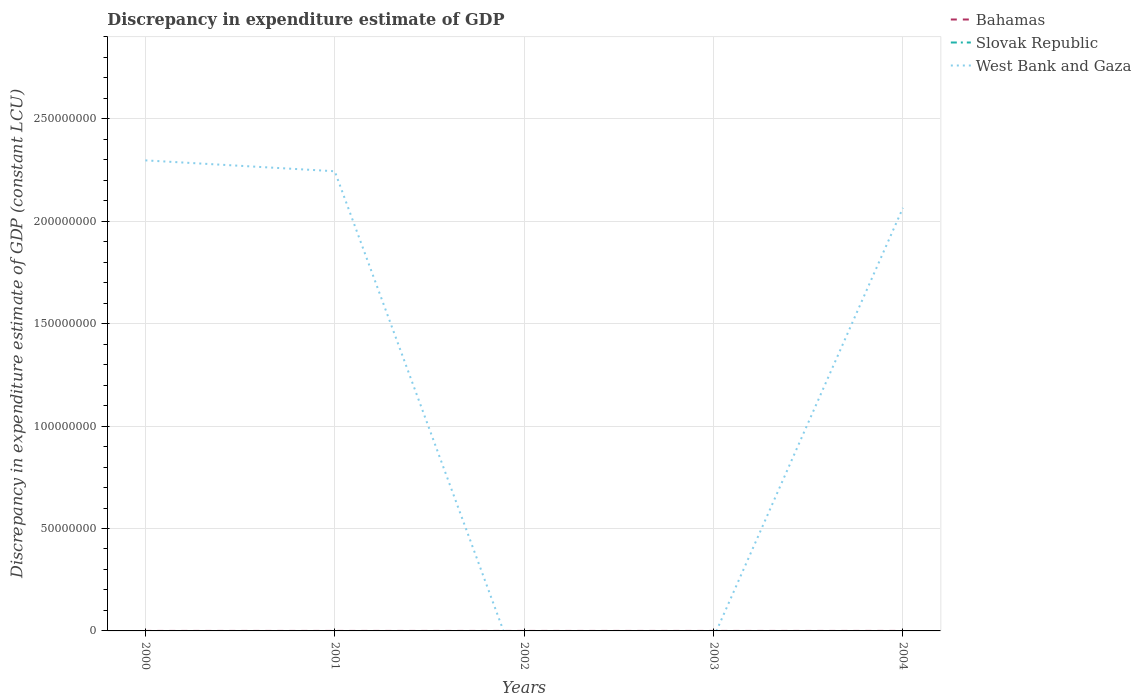How many different coloured lines are there?
Keep it short and to the point. 2. Is the number of lines equal to the number of legend labels?
Offer a very short reply. No. What is the total discrepancy in expenditure estimate of GDP in West Bank and Gaza in the graph?
Provide a succinct answer. 1.79e+07. What is the difference between the highest and the second highest discrepancy in expenditure estimate of GDP in West Bank and Gaza?
Provide a succinct answer. 2.30e+08. Is the discrepancy in expenditure estimate of GDP in Slovak Republic strictly greater than the discrepancy in expenditure estimate of GDP in Bahamas over the years?
Offer a terse response. Yes. How many lines are there?
Make the answer very short. 2. Are the values on the major ticks of Y-axis written in scientific E-notation?
Keep it short and to the point. No. Does the graph contain any zero values?
Your response must be concise. Yes. Does the graph contain grids?
Offer a very short reply. Yes. How many legend labels are there?
Offer a very short reply. 3. How are the legend labels stacked?
Give a very brief answer. Vertical. What is the title of the graph?
Your answer should be compact. Discrepancy in expenditure estimate of GDP. What is the label or title of the Y-axis?
Make the answer very short. Discrepancy in expenditure estimate of GDP (constant LCU). What is the Discrepancy in expenditure estimate of GDP (constant LCU) of Bahamas in 2000?
Provide a succinct answer. 0. What is the Discrepancy in expenditure estimate of GDP (constant LCU) in Slovak Republic in 2000?
Offer a very short reply. 0. What is the Discrepancy in expenditure estimate of GDP (constant LCU) of West Bank and Gaza in 2000?
Give a very brief answer. 2.30e+08. What is the Discrepancy in expenditure estimate of GDP (constant LCU) of West Bank and Gaza in 2001?
Make the answer very short. 2.24e+08. What is the Discrepancy in expenditure estimate of GDP (constant LCU) in Slovak Republic in 2002?
Keep it short and to the point. 0. What is the Discrepancy in expenditure estimate of GDP (constant LCU) of Slovak Republic in 2003?
Offer a terse response. 0. What is the Discrepancy in expenditure estimate of GDP (constant LCU) of Bahamas in 2004?
Ensure brevity in your answer.  5000. What is the Discrepancy in expenditure estimate of GDP (constant LCU) in Slovak Republic in 2004?
Ensure brevity in your answer.  0. What is the Discrepancy in expenditure estimate of GDP (constant LCU) of West Bank and Gaza in 2004?
Give a very brief answer. 2.07e+08. Across all years, what is the maximum Discrepancy in expenditure estimate of GDP (constant LCU) of West Bank and Gaza?
Your response must be concise. 2.30e+08. Across all years, what is the minimum Discrepancy in expenditure estimate of GDP (constant LCU) in Bahamas?
Offer a very short reply. 0. What is the total Discrepancy in expenditure estimate of GDP (constant LCU) of West Bank and Gaza in the graph?
Your answer should be compact. 6.61e+08. What is the difference between the Discrepancy in expenditure estimate of GDP (constant LCU) in West Bank and Gaza in 2000 and that in 2001?
Ensure brevity in your answer.  5.31e+06. What is the difference between the Discrepancy in expenditure estimate of GDP (constant LCU) in West Bank and Gaza in 2000 and that in 2004?
Provide a succinct answer. 2.32e+07. What is the difference between the Discrepancy in expenditure estimate of GDP (constant LCU) in West Bank and Gaza in 2001 and that in 2004?
Your response must be concise. 1.79e+07. What is the average Discrepancy in expenditure estimate of GDP (constant LCU) of Bahamas per year?
Make the answer very short. 1000. What is the average Discrepancy in expenditure estimate of GDP (constant LCU) of West Bank and Gaza per year?
Give a very brief answer. 1.32e+08. In the year 2004, what is the difference between the Discrepancy in expenditure estimate of GDP (constant LCU) in Bahamas and Discrepancy in expenditure estimate of GDP (constant LCU) in West Bank and Gaza?
Keep it short and to the point. -2.07e+08. What is the ratio of the Discrepancy in expenditure estimate of GDP (constant LCU) in West Bank and Gaza in 2000 to that in 2001?
Your response must be concise. 1.02. What is the ratio of the Discrepancy in expenditure estimate of GDP (constant LCU) in West Bank and Gaza in 2000 to that in 2004?
Your answer should be very brief. 1.11. What is the ratio of the Discrepancy in expenditure estimate of GDP (constant LCU) in West Bank and Gaza in 2001 to that in 2004?
Keep it short and to the point. 1.09. What is the difference between the highest and the second highest Discrepancy in expenditure estimate of GDP (constant LCU) of West Bank and Gaza?
Your answer should be very brief. 5.31e+06. What is the difference between the highest and the lowest Discrepancy in expenditure estimate of GDP (constant LCU) of Bahamas?
Offer a very short reply. 5000. What is the difference between the highest and the lowest Discrepancy in expenditure estimate of GDP (constant LCU) of West Bank and Gaza?
Keep it short and to the point. 2.30e+08. 